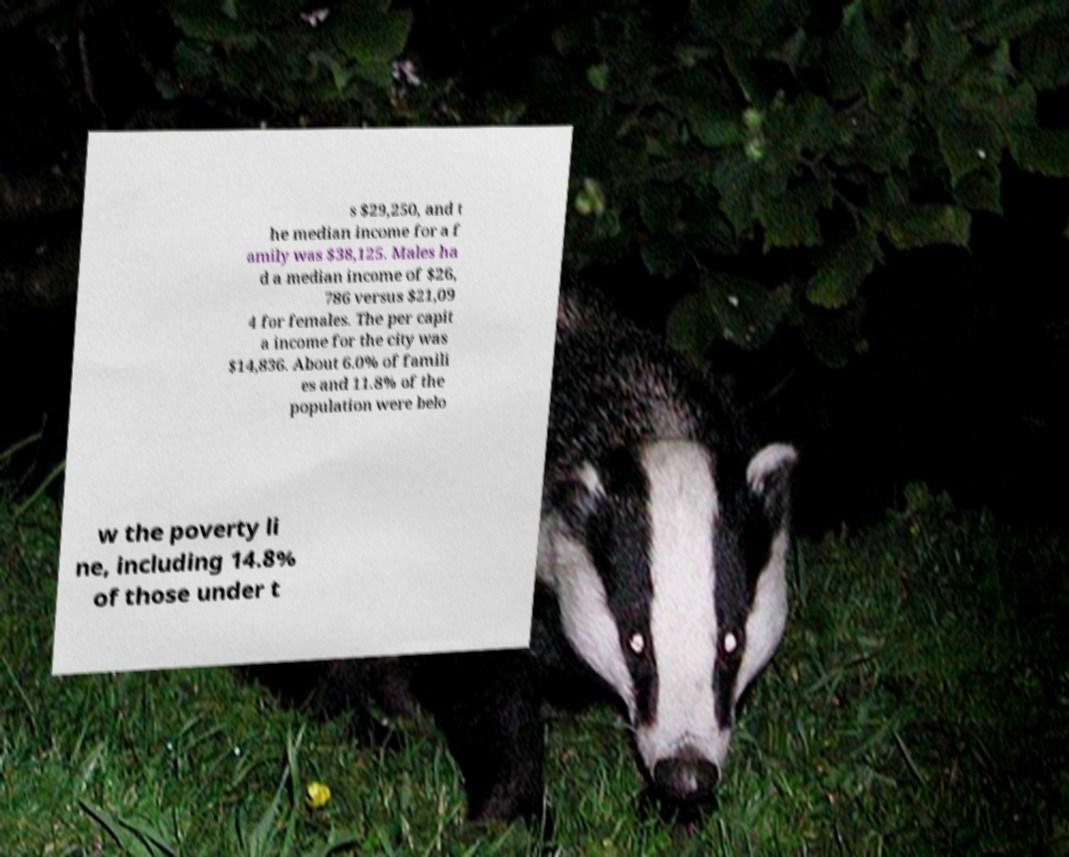For documentation purposes, I need the text within this image transcribed. Could you provide that? s $29,250, and t he median income for a f amily was $38,125. Males ha d a median income of $26, 786 versus $21,09 4 for females. The per capit a income for the city was $14,836. About 6.0% of famili es and 11.8% of the population were belo w the poverty li ne, including 14.8% of those under t 